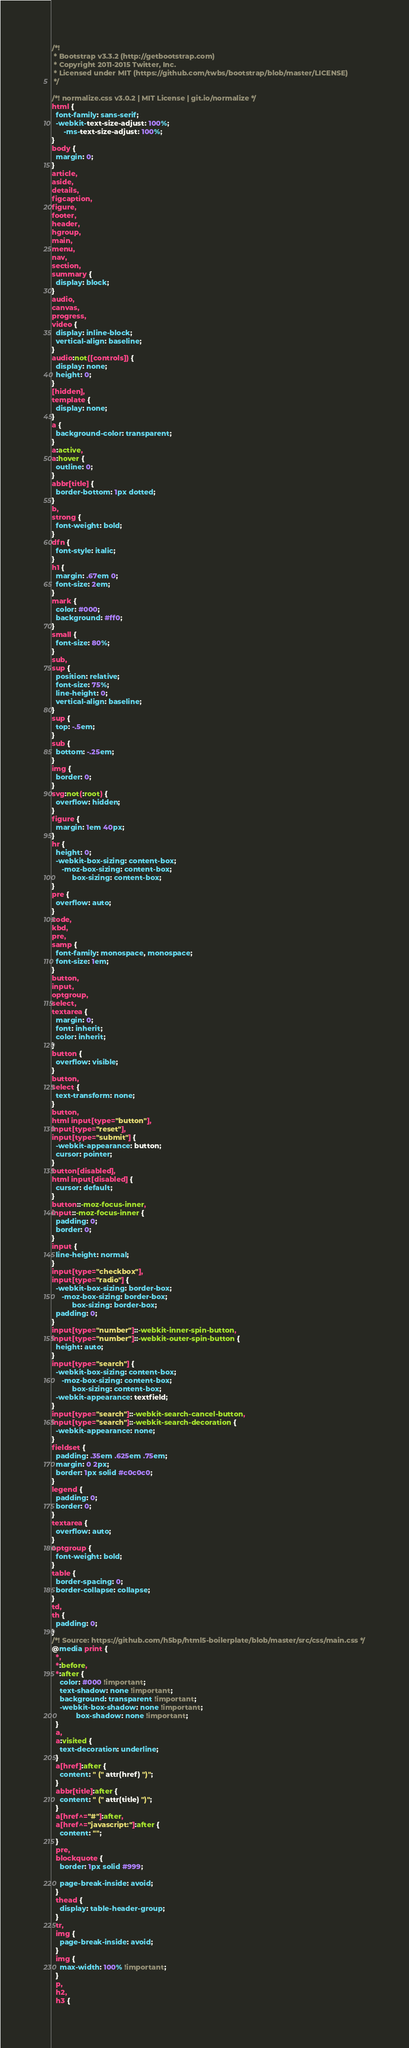<code> <loc_0><loc_0><loc_500><loc_500><_CSS_>/*!
 * Bootstrap v3.3.2 (http://getbootstrap.com)
 * Copyright 2011-2015 Twitter, Inc.
 * Licensed under MIT (https://github.com/twbs/bootstrap/blob/master/LICENSE)
 */

/*! normalize.css v3.0.2 | MIT License | git.io/normalize */
html {
  font-family: sans-serif;
  -webkit-text-size-adjust: 100%;
      -ms-text-size-adjust: 100%;
}
body {
  margin: 0;
}
article,
aside,
details,
figcaption,
figure,
footer,
header,
hgroup,
main,
menu,
nav,
section,
summary {
  display: block;
}
audio,
canvas,
progress,
video {
  display: inline-block;
  vertical-align: baseline;
}
audio:not([controls]) {
  display: none;
  height: 0;
}
[hidden],
template {
  display: none;
}
a {
  background-color: transparent;
}
a:active,
a:hover {
  outline: 0;
}
abbr[title] {
  border-bottom: 1px dotted;
}
b,
strong {
  font-weight: bold;
}
dfn {
  font-style: italic;
}
h1 {
  margin: .67em 0;
  font-size: 2em;
}
mark {
  color: #000;
  background: #ff0;
}
small {
  font-size: 80%;
}
sub,
sup {
  position: relative;
  font-size: 75%;
  line-height: 0;
  vertical-align: baseline;
}
sup {
  top: -.5em;
}
sub {
  bottom: -.25em;
}
img {
  border: 0;
}
svg:not(:root) {
  overflow: hidden;
}
figure {
  margin: 1em 40px;
}
hr {
  height: 0;
  -webkit-box-sizing: content-box;
     -moz-box-sizing: content-box;
          box-sizing: content-box;
}
pre {
  overflow: auto;
}
code,
kbd,
pre,
samp {
  font-family: monospace, monospace;
  font-size: 1em;
}
button,
input,
optgroup,
select,
textarea {
  margin: 0;
  font: inherit;
  color: inherit;
}
button {
  overflow: visible;
}
button,
select {
  text-transform: none;
}
button,
html input[type="button"],
input[type="reset"],
input[type="submit"] {
  -webkit-appearance: button;
  cursor: pointer;
}
button[disabled],
html input[disabled] {
  cursor: default;
}
button::-moz-focus-inner,
input::-moz-focus-inner {
  padding: 0;
  border: 0;
}
input {
  line-height: normal;
}
input[type="checkbox"],
input[type="radio"] {
  -webkit-box-sizing: border-box;
     -moz-box-sizing: border-box;
          box-sizing: border-box;
  padding: 0;
}
input[type="number"]::-webkit-inner-spin-button,
input[type="number"]::-webkit-outer-spin-button {
  height: auto;
}
input[type="search"] {
  -webkit-box-sizing: content-box;
     -moz-box-sizing: content-box;
          box-sizing: content-box;
  -webkit-appearance: textfield;
}
input[type="search"]::-webkit-search-cancel-button,
input[type="search"]::-webkit-search-decoration {
  -webkit-appearance: none;
}
fieldset {
  padding: .35em .625em .75em;
  margin: 0 2px;
  border: 1px solid #c0c0c0;
}
legend {
  padding: 0;
  border: 0;
}
textarea {
  overflow: auto;
}
optgroup {
  font-weight: bold;
}
table {
  border-spacing: 0;
  border-collapse: collapse;
}
td,
th {
  padding: 0;
}
/*! Source: https://github.com/h5bp/html5-boilerplate/blob/master/src/css/main.css */
@media print {
  *,
  *:before,
  *:after {
    color: #000 !important;
    text-shadow: none !important;
    background: transparent !important;
    -webkit-box-shadow: none !important;
            box-shadow: none !important;
  }
  a,
  a:visited {
    text-decoration: underline;
  }
  a[href]:after {
    content: " (" attr(href) ")";
  }
  abbr[title]:after {
    content: " (" attr(title) ")";
  }
  a[href^="#"]:after,
  a[href^="javascript:"]:after {
    content: "";
  }
  pre,
  blockquote {
    border: 1px solid #999;

    page-break-inside: avoid;
  }
  thead {
    display: table-header-group;
  }
  tr,
  img {
    page-break-inside: avoid;
  }
  img {
    max-width: 100% !important;
  }
  p,
  h2,
  h3 {</code> 